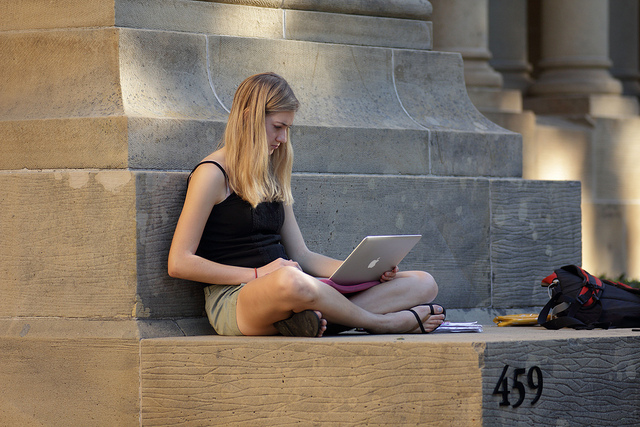Please transcribe the text in this image. 459 